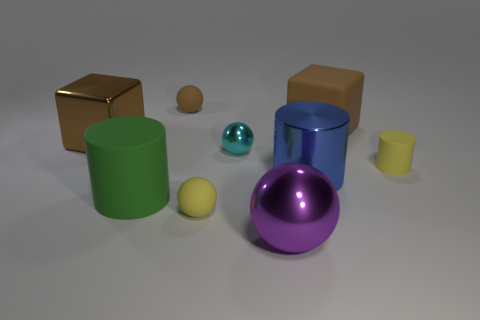Does the large shiny block have the same color as the rubber block?
Your response must be concise. Yes. There is a yellow object to the left of the small cylinder that is right of the small ball in front of the blue cylinder; what size is it?
Provide a succinct answer. Small. How many other things are there of the same size as the cyan metal sphere?
Your answer should be very brief. 3. What is the size of the matte cylinder that is on the right side of the big blue metal object?
Provide a short and direct response. Small. Is there any other thing of the same color as the large metallic sphere?
Offer a very short reply. No. Are the large thing that is left of the green object and the small brown thing made of the same material?
Your response must be concise. No. What number of rubber cylinders are right of the small yellow sphere and on the left side of the small brown rubber thing?
Your response must be concise. 0. There is a thing that is behind the big rubber block right of the purple sphere; how big is it?
Make the answer very short. Small. Are there more tiny shiny objects than matte cylinders?
Make the answer very short. No. Is the color of the tiny rubber object that is on the right side of the large purple shiny object the same as the rubber thing that is in front of the green rubber cylinder?
Give a very brief answer. Yes. 